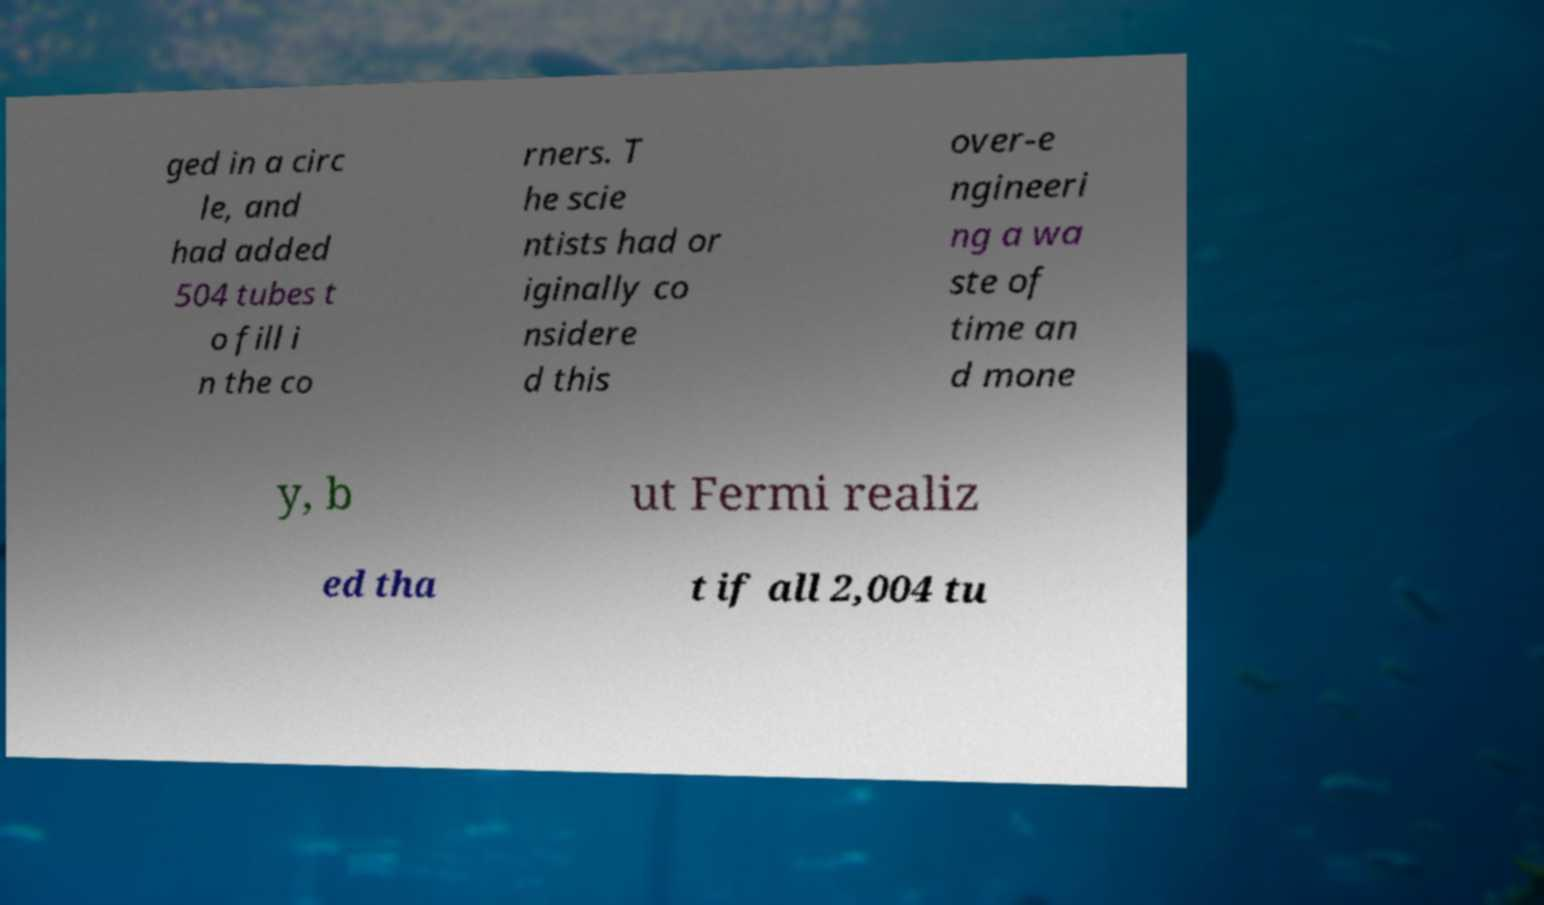Please read and relay the text visible in this image. What does it say? ged in a circ le, and had added 504 tubes t o fill i n the co rners. T he scie ntists had or iginally co nsidere d this over-e ngineeri ng a wa ste of time an d mone y, b ut Fermi realiz ed tha t if all 2,004 tu 